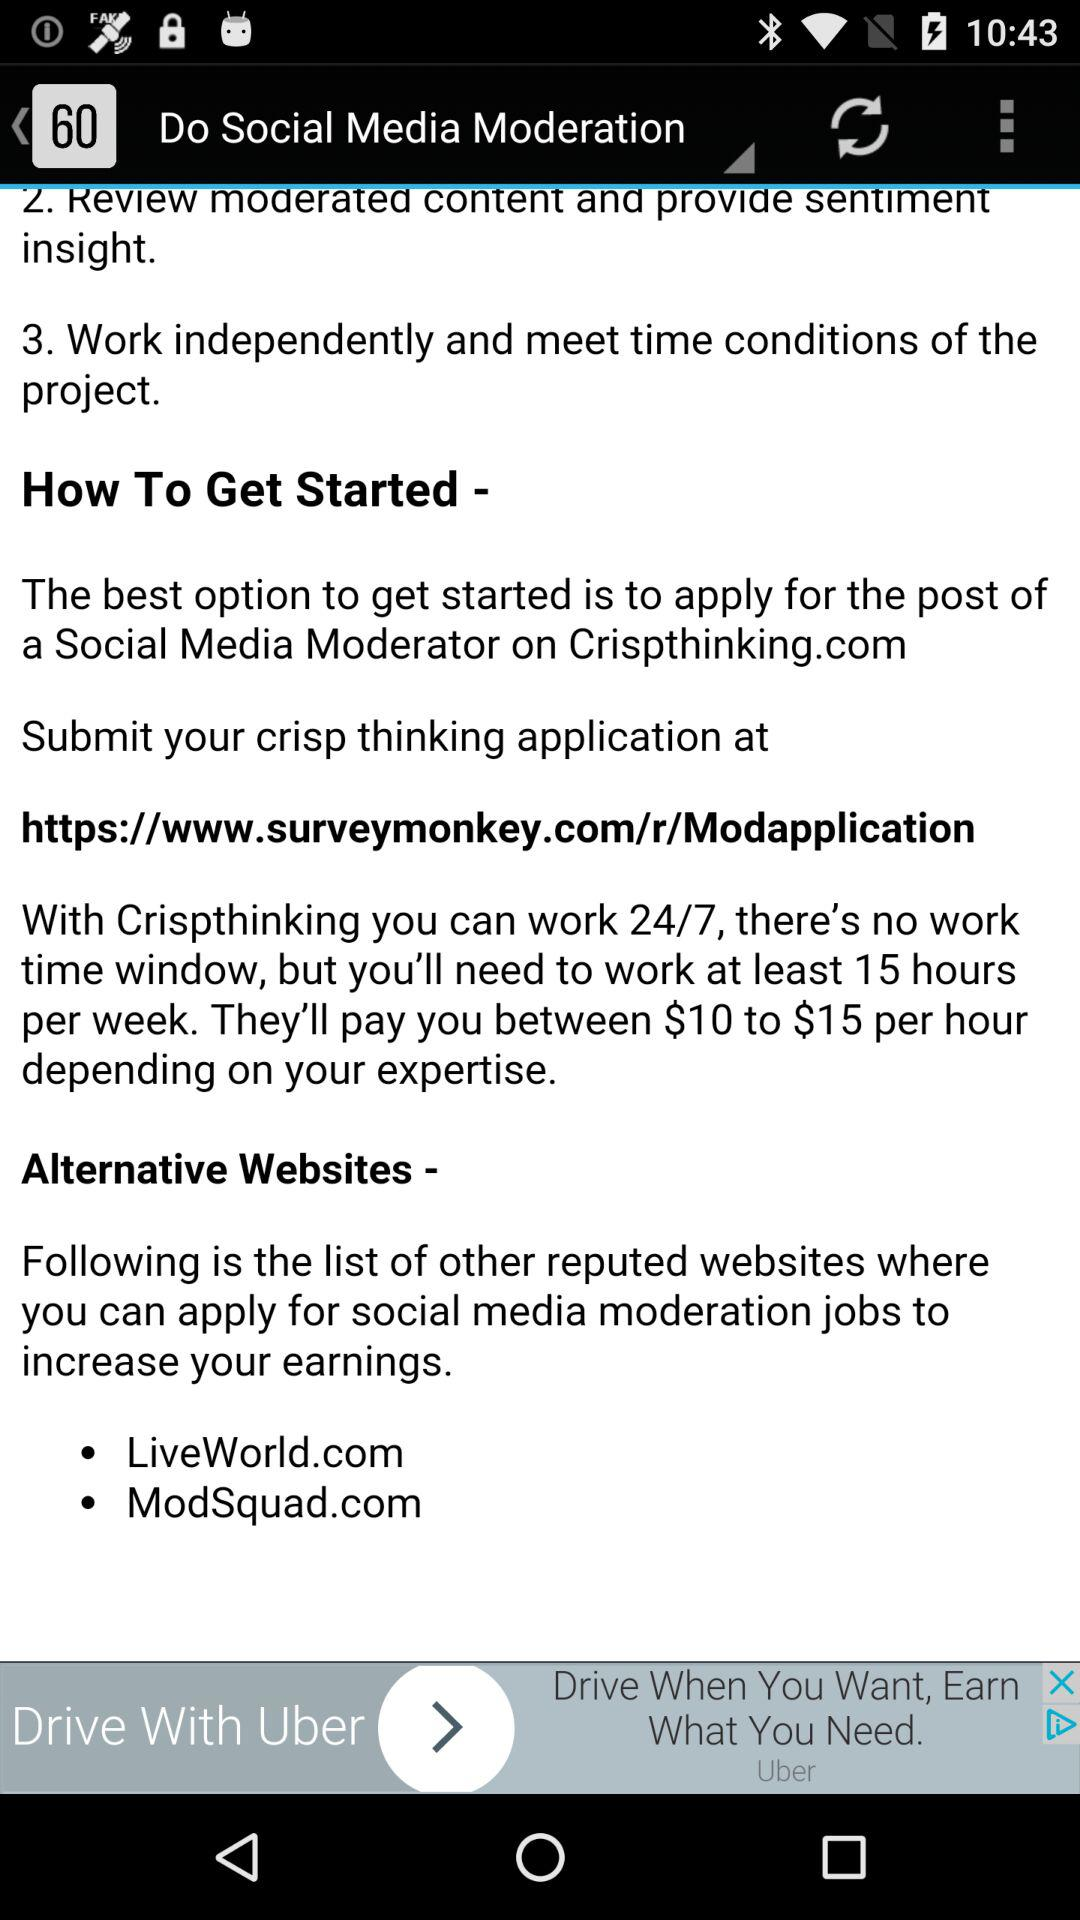How much are they going to pay per hour? They are going to pay between $10 to $15. 